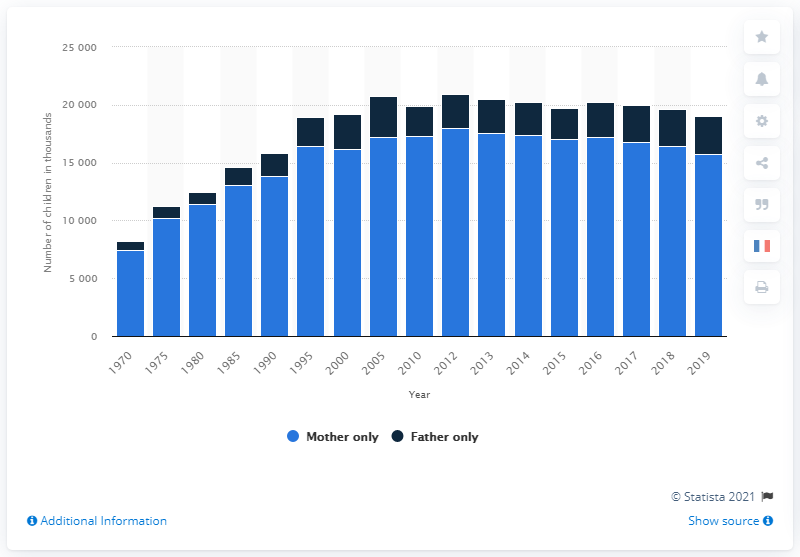Outline some significant characteristics in this image. In 2005, the number of children living with a single father reached its peak. In 2012, the number of children living with a single mother reached its peak. 